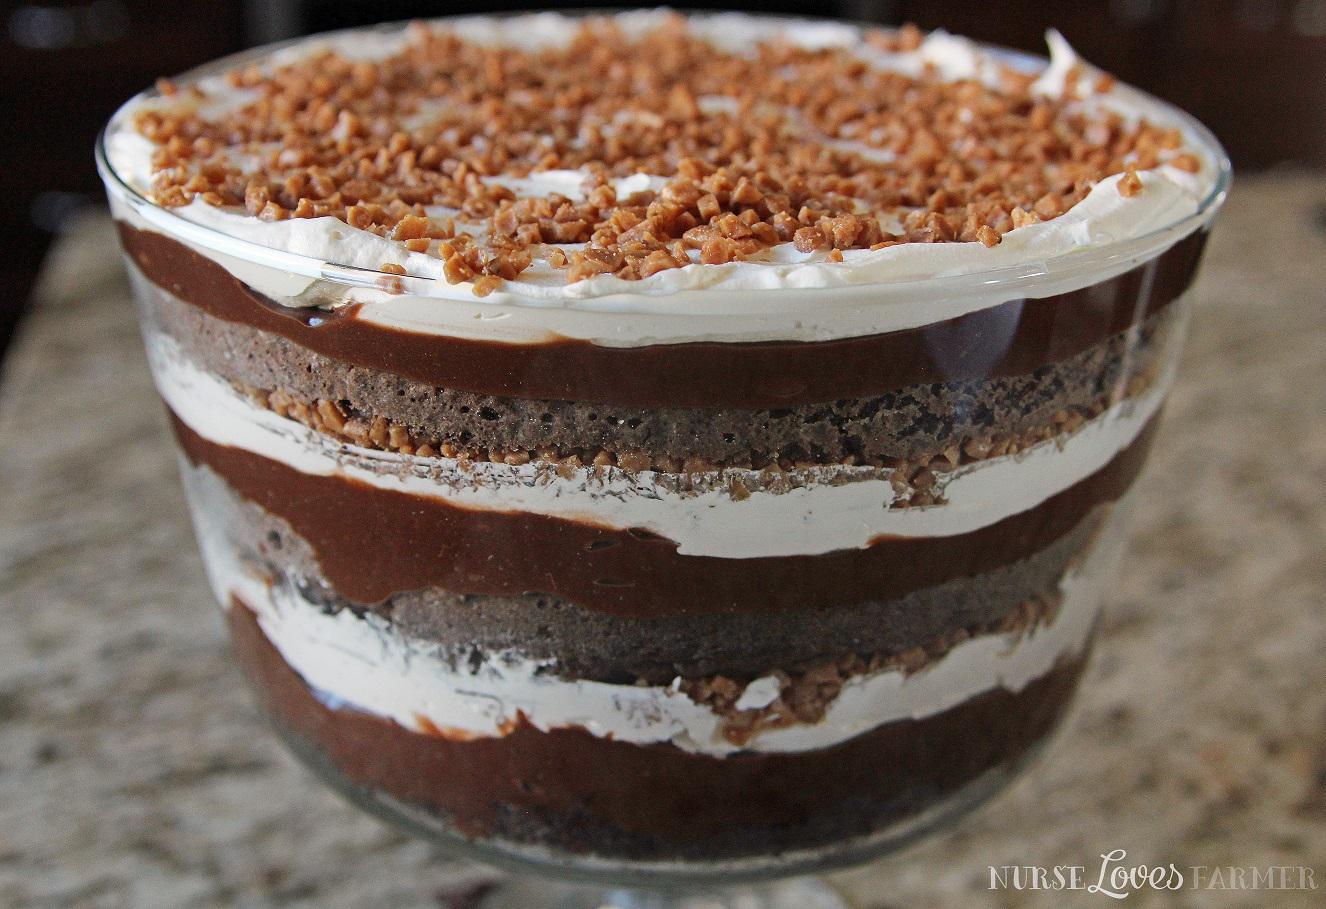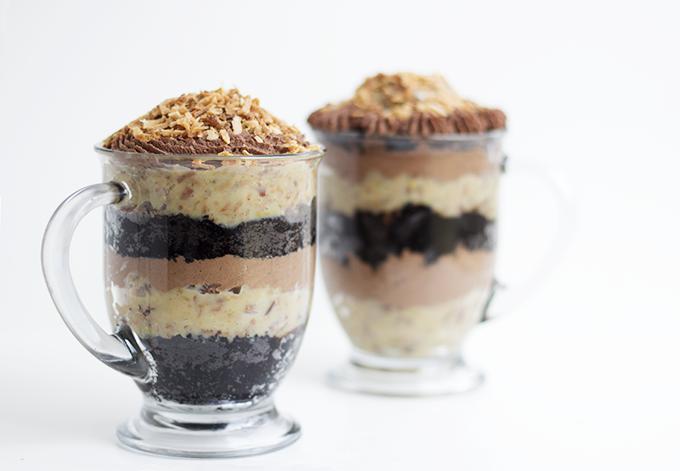The first image is the image on the left, the second image is the image on the right. Evaluate the accuracy of this statement regarding the images: "There are two desserts in one of the images". Is it true? Answer yes or no. Yes. The first image is the image on the left, the second image is the image on the right. Given the left and right images, does the statement "Two large chocolate desserts have multiple chocolate and white layers, with sprinkles in the top white layer." hold true? Answer yes or no. No. 